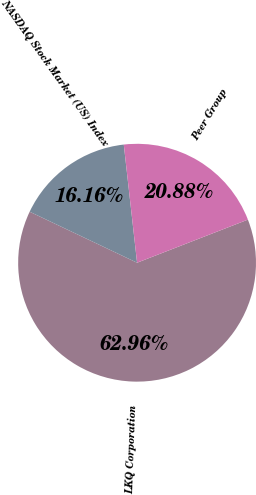Convert chart to OTSL. <chart><loc_0><loc_0><loc_500><loc_500><pie_chart><fcel>LKQ Corporation<fcel>NASDAQ Stock Market (US) Index<fcel>Peer Group<nl><fcel>62.96%<fcel>16.16%<fcel>20.88%<nl></chart> 